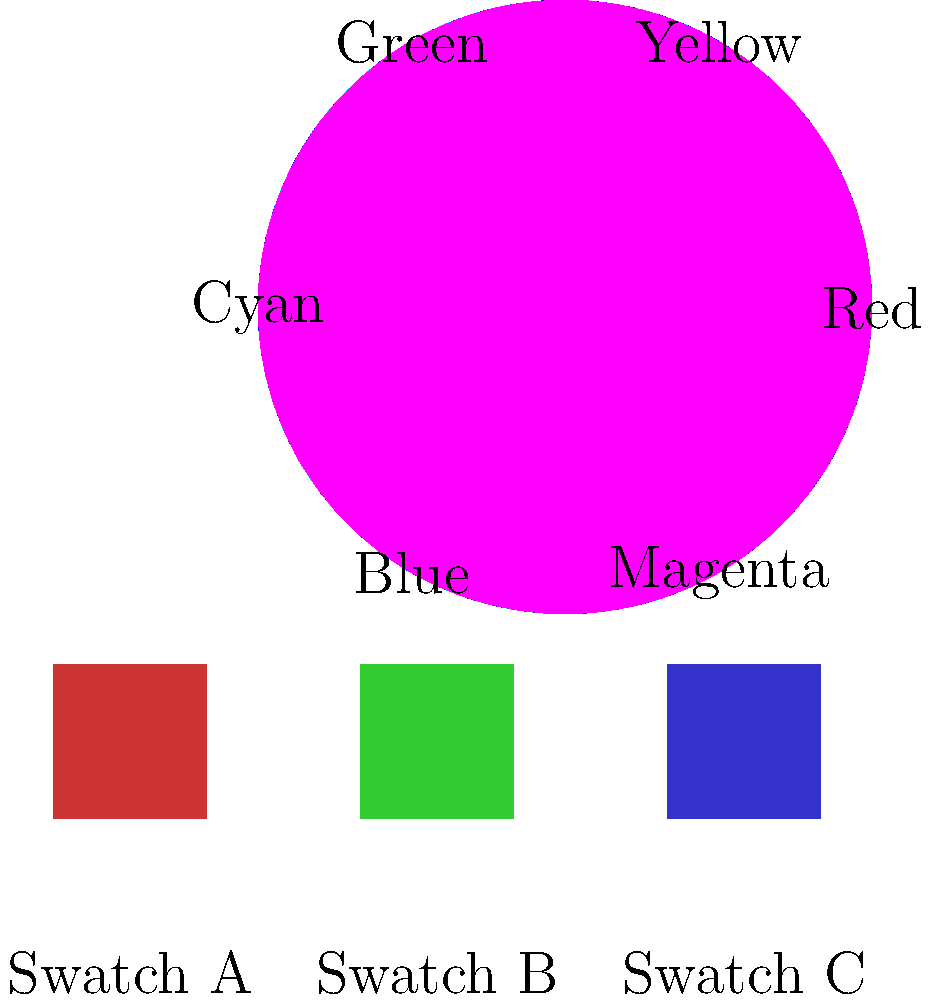In a costume design for Sandra Bullock's character in a romantic comedy, you need to create a harmonious color scheme. Using the color wheel and fabric swatches provided, which color theory principle would you apply to combine Swatch A (red) with one of the other swatches to create a balanced, visually appealing outfit? To answer this question, let's follow these steps:

1. Identify the color of Swatch A: It's red.

2. Recall color theory principles:
   - Complementary colors: opposite on the color wheel
   - Analogous colors: adjacent on the color wheel
   - Triadic colors: evenly spaced on the color wheel

3. Analyze the other swatches:
   - Swatch B is green
   - Swatch C is blue

4. Apply color theory principles:
   - Red and green are complementary colors (opposite on the wheel)
   - Red and blue are not directly complementary but can create a bold contrast

5. Consider the context:
   - It's a romantic comedy, so a balanced yet vibrant look is appropriate
   - Complementary colors create high contrast and visual interest

6. Make a decision:
   - Combining Swatch A (red) with Swatch B (green) would apply the complementary color principle
   - This combination creates a balanced, visually appealing outfit suitable for a romantic comedy

7. Reflect on past experiences:
   - In Sandra Bullock films, complementary color schemes often create memorable, eye-catching costumes that pop on screen
Answer: Complementary color principle 